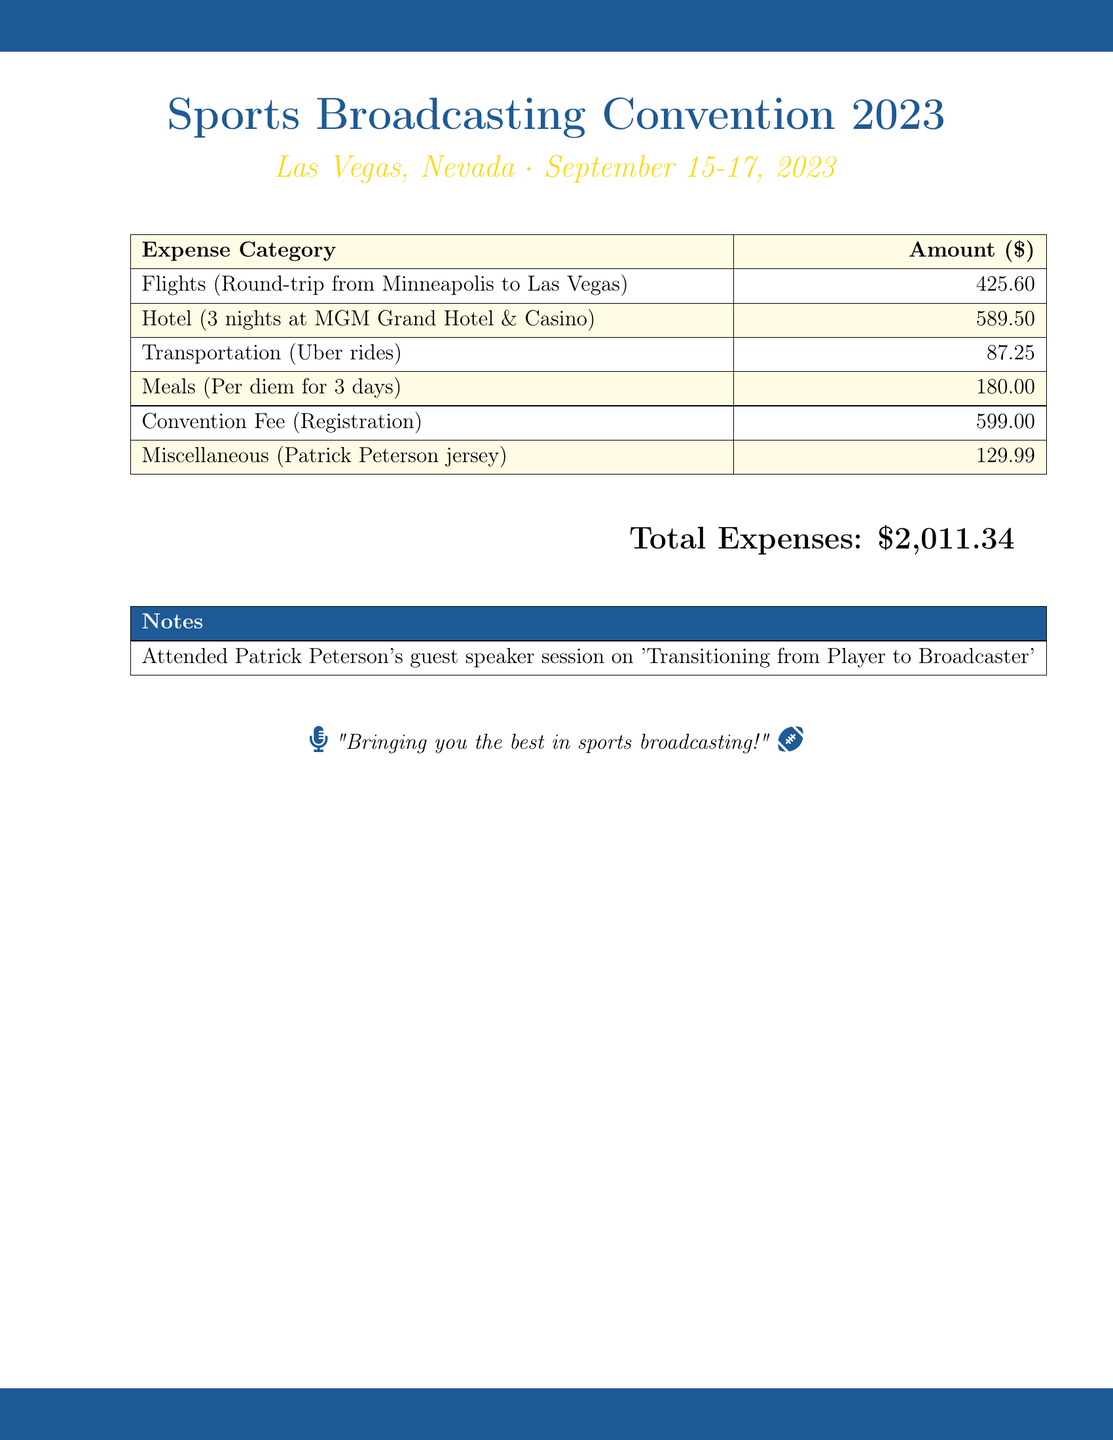What is the total expense amount? The total expense is the sum of all the listed expenses, which amounts to $2,011.34.
Answer: $2,011.34 How many nights was the hotel stay? The hotel stay was for 3 nights at the MGM Grand Hotel & Casino.
Answer: 3 nights What was the cost of the registration fee? The registration fee for the convention was listed as $599.00.
Answer: $599.00 What type of transportation was used? The transportation used for the trip was Uber rides.
Answer: Uber rides What was the per diem for meals? The per diem amount for meals over 3 days totaled $180.00.
Answer: $180.00 Who was the guest speaker during the session? The guest speaker was Patrick Peterson, who hosted a session on transitioning from player to broadcaster.
Answer: Patrick Peterson What is the cost of the Patrick Peterson jersey? The expense for the Patrick Peterson jersey was listed as $129.99.
Answer: $129.99 In which city was the convention held? The convention took place in Las Vegas, Nevada.
Answer: Las Vegas What dates did the convention occur? The convention occurred from September 15-17, 2023.
Answer: September 15-17, 2023 